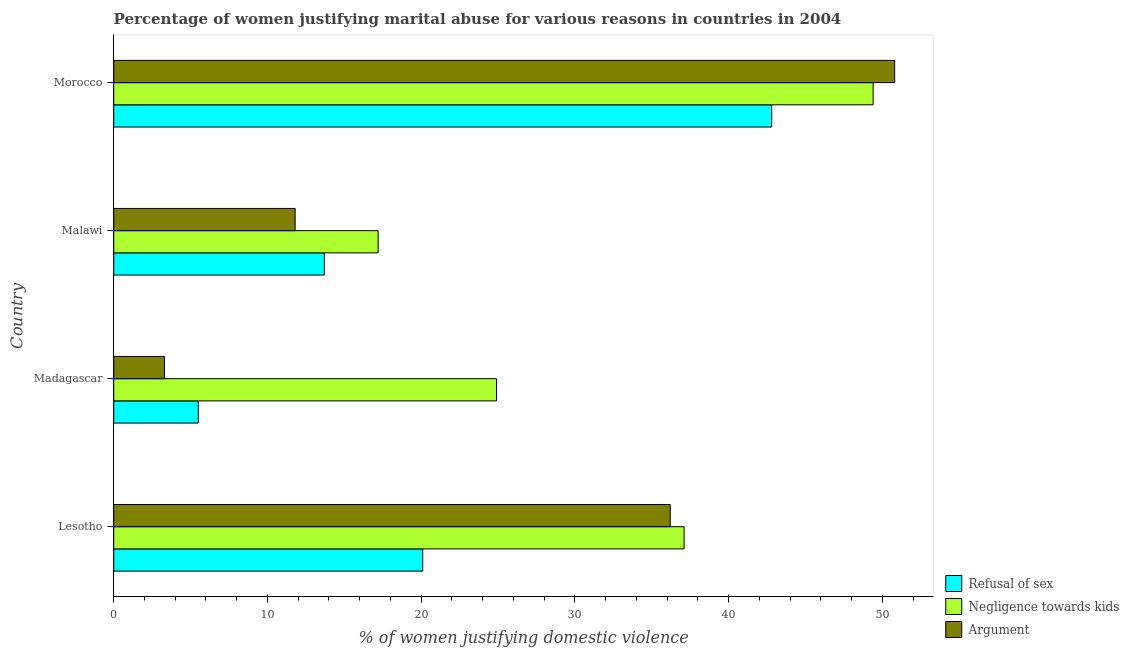How many different coloured bars are there?
Keep it short and to the point. 3. How many groups of bars are there?
Your answer should be compact. 4. How many bars are there on the 4th tick from the top?
Your response must be concise. 3. What is the label of the 2nd group of bars from the top?
Give a very brief answer. Malawi. In how many cases, is the number of bars for a given country not equal to the number of legend labels?
Keep it short and to the point. 0. What is the percentage of women justifying domestic violence due to refusal of sex in Lesotho?
Ensure brevity in your answer.  20.1. Across all countries, what is the maximum percentage of women justifying domestic violence due to arguments?
Offer a very short reply. 50.8. In which country was the percentage of women justifying domestic violence due to refusal of sex maximum?
Keep it short and to the point. Morocco. In which country was the percentage of women justifying domestic violence due to refusal of sex minimum?
Keep it short and to the point. Madagascar. What is the total percentage of women justifying domestic violence due to negligence towards kids in the graph?
Keep it short and to the point. 128.6. What is the difference between the percentage of women justifying domestic violence due to refusal of sex in Malawi and that in Morocco?
Your answer should be very brief. -29.1. What is the difference between the percentage of women justifying domestic violence due to negligence towards kids in Morocco and the percentage of women justifying domestic violence due to arguments in Malawi?
Your answer should be very brief. 37.6. What is the average percentage of women justifying domestic violence due to negligence towards kids per country?
Give a very brief answer. 32.15. In how many countries, is the percentage of women justifying domestic violence due to arguments greater than 42 %?
Offer a very short reply. 1. What is the ratio of the percentage of women justifying domestic violence due to arguments in Madagascar to that in Morocco?
Give a very brief answer. 0.07. What is the difference between the highest and the second highest percentage of women justifying domestic violence due to arguments?
Offer a terse response. 14.6. What is the difference between the highest and the lowest percentage of women justifying domestic violence due to negligence towards kids?
Provide a short and direct response. 32.2. Is the sum of the percentage of women justifying domestic violence due to arguments in Lesotho and Madagascar greater than the maximum percentage of women justifying domestic violence due to refusal of sex across all countries?
Make the answer very short. No. What does the 1st bar from the top in Lesotho represents?
Make the answer very short. Argument. What does the 2nd bar from the bottom in Morocco represents?
Make the answer very short. Negligence towards kids. Is it the case that in every country, the sum of the percentage of women justifying domestic violence due to refusal of sex and percentage of women justifying domestic violence due to negligence towards kids is greater than the percentage of women justifying domestic violence due to arguments?
Your answer should be compact. Yes. How many bars are there?
Your answer should be compact. 12. Are all the bars in the graph horizontal?
Provide a succinct answer. Yes. Are the values on the major ticks of X-axis written in scientific E-notation?
Keep it short and to the point. No. Does the graph contain any zero values?
Offer a very short reply. No. Does the graph contain grids?
Make the answer very short. No. Where does the legend appear in the graph?
Keep it short and to the point. Bottom right. How many legend labels are there?
Ensure brevity in your answer.  3. How are the legend labels stacked?
Ensure brevity in your answer.  Vertical. What is the title of the graph?
Give a very brief answer. Percentage of women justifying marital abuse for various reasons in countries in 2004. Does "Gaseous fuel" appear as one of the legend labels in the graph?
Offer a very short reply. No. What is the label or title of the X-axis?
Your response must be concise. % of women justifying domestic violence. What is the % of women justifying domestic violence of Refusal of sex in Lesotho?
Give a very brief answer. 20.1. What is the % of women justifying domestic violence in Negligence towards kids in Lesotho?
Offer a terse response. 37.1. What is the % of women justifying domestic violence of Argument in Lesotho?
Ensure brevity in your answer.  36.2. What is the % of women justifying domestic violence in Negligence towards kids in Madagascar?
Provide a succinct answer. 24.9. What is the % of women justifying domestic violence in Refusal of sex in Malawi?
Keep it short and to the point. 13.7. What is the % of women justifying domestic violence in Refusal of sex in Morocco?
Offer a terse response. 42.8. What is the % of women justifying domestic violence in Negligence towards kids in Morocco?
Your response must be concise. 49.4. What is the % of women justifying domestic violence of Argument in Morocco?
Offer a terse response. 50.8. Across all countries, what is the maximum % of women justifying domestic violence of Refusal of sex?
Your answer should be very brief. 42.8. Across all countries, what is the maximum % of women justifying domestic violence in Negligence towards kids?
Ensure brevity in your answer.  49.4. Across all countries, what is the maximum % of women justifying domestic violence in Argument?
Your response must be concise. 50.8. Across all countries, what is the minimum % of women justifying domestic violence of Negligence towards kids?
Give a very brief answer. 17.2. Across all countries, what is the minimum % of women justifying domestic violence of Argument?
Your response must be concise. 3.3. What is the total % of women justifying domestic violence in Refusal of sex in the graph?
Your answer should be compact. 82.1. What is the total % of women justifying domestic violence in Negligence towards kids in the graph?
Provide a short and direct response. 128.6. What is the total % of women justifying domestic violence of Argument in the graph?
Make the answer very short. 102.1. What is the difference between the % of women justifying domestic violence in Argument in Lesotho and that in Madagascar?
Provide a short and direct response. 32.9. What is the difference between the % of women justifying domestic violence of Refusal of sex in Lesotho and that in Malawi?
Offer a very short reply. 6.4. What is the difference between the % of women justifying domestic violence in Argument in Lesotho and that in Malawi?
Offer a terse response. 24.4. What is the difference between the % of women justifying domestic violence in Refusal of sex in Lesotho and that in Morocco?
Your answer should be compact. -22.7. What is the difference between the % of women justifying domestic violence in Argument in Lesotho and that in Morocco?
Make the answer very short. -14.6. What is the difference between the % of women justifying domestic violence of Argument in Madagascar and that in Malawi?
Offer a terse response. -8.5. What is the difference between the % of women justifying domestic violence of Refusal of sex in Madagascar and that in Morocco?
Provide a short and direct response. -37.3. What is the difference between the % of women justifying domestic violence of Negligence towards kids in Madagascar and that in Morocco?
Keep it short and to the point. -24.5. What is the difference between the % of women justifying domestic violence of Argument in Madagascar and that in Morocco?
Provide a succinct answer. -47.5. What is the difference between the % of women justifying domestic violence in Refusal of sex in Malawi and that in Morocco?
Provide a short and direct response. -29.1. What is the difference between the % of women justifying domestic violence in Negligence towards kids in Malawi and that in Morocco?
Provide a short and direct response. -32.2. What is the difference between the % of women justifying domestic violence in Argument in Malawi and that in Morocco?
Your answer should be compact. -39. What is the difference between the % of women justifying domestic violence of Negligence towards kids in Lesotho and the % of women justifying domestic violence of Argument in Madagascar?
Offer a very short reply. 33.8. What is the difference between the % of women justifying domestic violence of Refusal of sex in Lesotho and the % of women justifying domestic violence of Negligence towards kids in Malawi?
Offer a very short reply. 2.9. What is the difference between the % of women justifying domestic violence in Negligence towards kids in Lesotho and the % of women justifying domestic violence in Argument in Malawi?
Ensure brevity in your answer.  25.3. What is the difference between the % of women justifying domestic violence in Refusal of sex in Lesotho and the % of women justifying domestic violence in Negligence towards kids in Morocco?
Provide a short and direct response. -29.3. What is the difference between the % of women justifying domestic violence in Refusal of sex in Lesotho and the % of women justifying domestic violence in Argument in Morocco?
Offer a very short reply. -30.7. What is the difference between the % of women justifying domestic violence in Negligence towards kids in Lesotho and the % of women justifying domestic violence in Argument in Morocco?
Provide a succinct answer. -13.7. What is the difference between the % of women justifying domestic violence in Refusal of sex in Madagascar and the % of women justifying domestic violence in Negligence towards kids in Malawi?
Your response must be concise. -11.7. What is the difference between the % of women justifying domestic violence of Refusal of sex in Madagascar and the % of women justifying domestic violence of Negligence towards kids in Morocco?
Keep it short and to the point. -43.9. What is the difference between the % of women justifying domestic violence of Refusal of sex in Madagascar and the % of women justifying domestic violence of Argument in Morocco?
Your answer should be very brief. -45.3. What is the difference between the % of women justifying domestic violence of Negligence towards kids in Madagascar and the % of women justifying domestic violence of Argument in Morocco?
Your answer should be very brief. -25.9. What is the difference between the % of women justifying domestic violence of Refusal of sex in Malawi and the % of women justifying domestic violence of Negligence towards kids in Morocco?
Your response must be concise. -35.7. What is the difference between the % of women justifying domestic violence of Refusal of sex in Malawi and the % of women justifying domestic violence of Argument in Morocco?
Provide a succinct answer. -37.1. What is the difference between the % of women justifying domestic violence of Negligence towards kids in Malawi and the % of women justifying domestic violence of Argument in Morocco?
Your response must be concise. -33.6. What is the average % of women justifying domestic violence of Refusal of sex per country?
Offer a terse response. 20.52. What is the average % of women justifying domestic violence of Negligence towards kids per country?
Offer a terse response. 32.15. What is the average % of women justifying domestic violence of Argument per country?
Your answer should be compact. 25.52. What is the difference between the % of women justifying domestic violence in Refusal of sex and % of women justifying domestic violence in Argument in Lesotho?
Provide a succinct answer. -16.1. What is the difference between the % of women justifying domestic violence of Refusal of sex and % of women justifying domestic violence of Negligence towards kids in Madagascar?
Provide a succinct answer. -19.4. What is the difference between the % of women justifying domestic violence of Refusal of sex and % of women justifying domestic violence of Argument in Madagascar?
Offer a very short reply. 2.2. What is the difference between the % of women justifying domestic violence of Negligence towards kids and % of women justifying domestic violence of Argument in Madagascar?
Offer a terse response. 21.6. What is the difference between the % of women justifying domestic violence in Refusal of sex and % of women justifying domestic violence in Negligence towards kids in Morocco?
Ensure brevity in your answer.  -6.6. What is the difference between the % of women justifying domestic violence of Refusal of sex and % of women justifying domestic violence of Argument in Morocco?
Provide a succinct answer. -8. What is the difference between the % of women justifying domestic violence of Negligence towards kids and % of women justifying domestic violence of Argument in Morocco?
Make the answer very short. -1.4. What is the ratio of the % of women justifying domestic violence of Refusal of sex in Lesotho to that in Madagascar?
Provide a short and direct response. 3.65. What is the ratio of the % of women justifying domestic violence of Negligence towards kids in Lesotho to that in Madagascar?
Give a very brief answer. 1.49. What is the ratio of the % of women justifying domestic violence in Argument in Lesotho to that in Madagascar?
Your answer should be compact. 10.97. What is the ratio of the % of women justifying domestic violence of Refusal of sex in Lesotho to that in Malawi?
Offer a terse response. 1.47. What is the ratio of the % of women justifying domestic violence of Negligence towards kids in Lesotho to that in Malawi?
Your answer should be compact. 2.16. What is the ratio of the % of women justifying domestic violence of Argument in Lesotho to that in Malawi?
Ensure brevity in your answer.  3.07. What is the ratio of the % of women justifying domestic violence of Refusal of sex in Lesotho to that in Morocco?
Provide a succinct answer. 0.47. What is the ratio of the % of women justifying domestic violence in Negligence towards kids in Lesotho to that in Morocco?
Keep it short and to the point. 0.75. What is the ratio of the % of women justifying domestic violence of Argument in Lesotho to that in Morocco?
Your answer should be compact. 0.71. What is the ratio of the % of women justifying domestic violence of Refusal of sex in Madagascar to that in Malawi?
Your answer should be very brief. 0.4. What is the ratio of the % of women justifying domestic violence in Negligence towards kids in Madagascar to that in Malawi?
Your response must be concise. 1.45. What is the ratio of the % of women justifying domestic violence in Argument in Madagascar to that in Malawi?
Provide a succinct answer. 0.28. What is the ratio of the % of women justifying domestic violence of Refusal of sex in Madagascar to that in Morocco?
Offer a very short reply. 0.13. What is the ratio of the % of women justifying domestic violence of Negligence towards kids in Madagascar to that in Morocco?
Your response must be concise. 0.5. What is the ratio of the % of women justifying domestic violence in Argument in Madagascar to that in Morocco?
Provide a short and direct response. 0.07. What is the ratio of the % of women justifying domestic violence of Refusal of sex in Malawi to that in Morocco?
Provide a succinct answer. 0.32. What is the ratio of the % of women justifying domestic violence of Negligence towards kids in Malawi to that in Morocco?
Provide a short and direct response. 0.35. What is the ratio of the % of women justifying domestic violence in Argument in Malawi to that in Morocco?
Your response must be concise. 0.23. What is the difference between the highest and the second highest % of women justifying domestic violence of Refusal of sex?
Offer a very short reply. 22.7. What is the difference between the highest and the second highest % of women justifying domestic violence in Argument?
Offer a terse response. 14.6. What is the difference between the highest and the lowest % of women justifying domestic violence of Refusal of sex?
Provide a short and direct response. 37.3. What is the difference between the highest and the lowest % of women justifying domestic violence in Negligence towards kids?
Ensure brevity in your answer.  32.2. What is the difference between the highest and the lowest % of women justifying domestic violence of Argument?
Your answer should be compact. 47.5. 